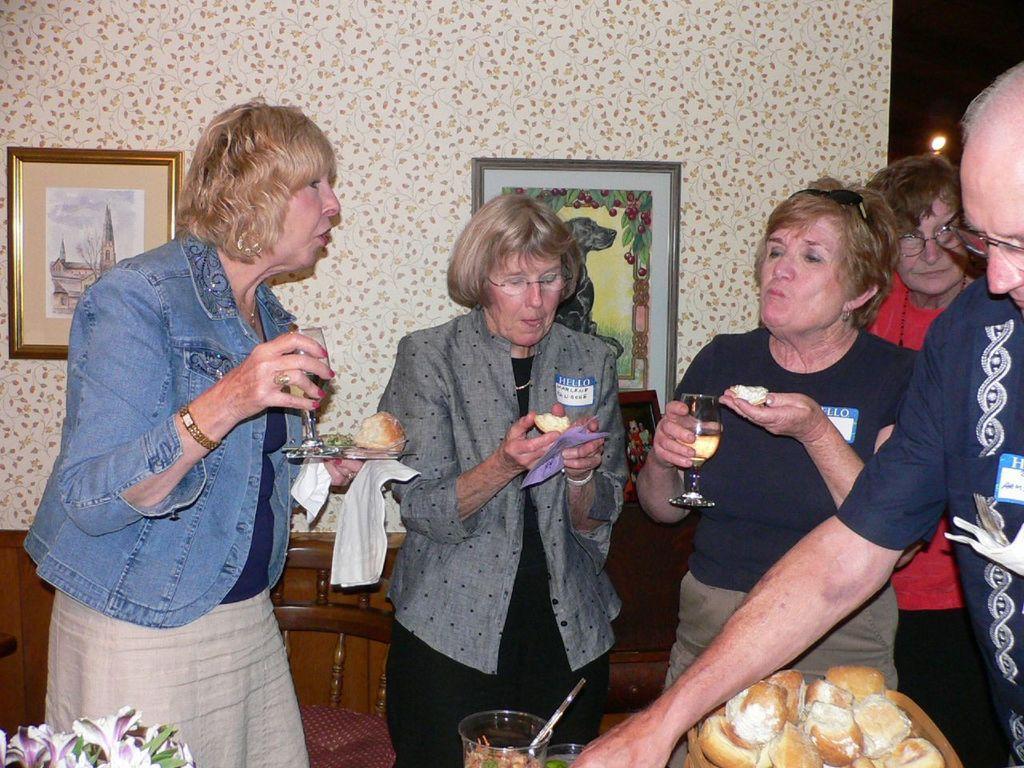How would you summarize this image in a sentence or two? In the background we can see the light and frames on the wall. We can see a frame on the platform. In this picture we can see the woman holding food and two women are holding glasses in their hands. On the right side of the picture we can see the people. At the bottom portion of the picture we can see the food in a container and glass object. We can see food in the glass object.. We can see flowers and green leaves. We can see a chair. 